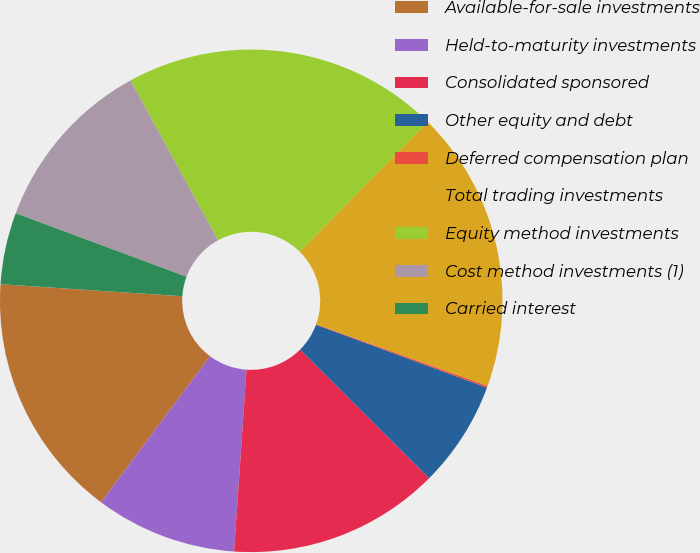Convert chart. <chart><loc_0><loc_0><loc_500><loc_500><pie_chart><fcel>Available-for-sale investments<fcel>Held-to-maturity investments<fcel>Consolidated sponsored<fcel>Other equity and debt<fcel>Deferred compensation plan<fcel>Total trading investments<fcel>Equity method investments<fcel>Cost method investments (1)<fcel>Carried interest<nl><fcel>15.86%<fcel>9.11%<fcel>13.61%<fcel>6.86%<fcel>0.12%<fcel>18.11%<fcel>20.36%<fcel>11.36%<fcel>4.61%<nl></chart> 